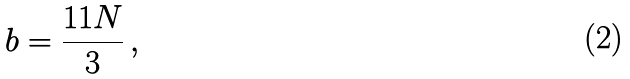Convert formula to latex. <formula><loc_0><loc_0><loc_500><loc_500>b = \frac { 1 1 N } { 3 } \, ,</formula> 